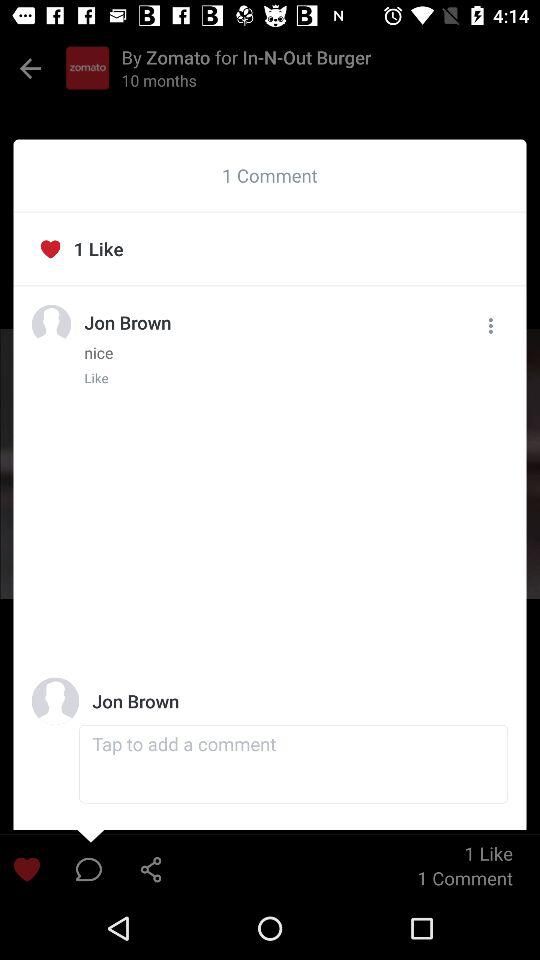What is the count of likes? The count of likes is 1. 